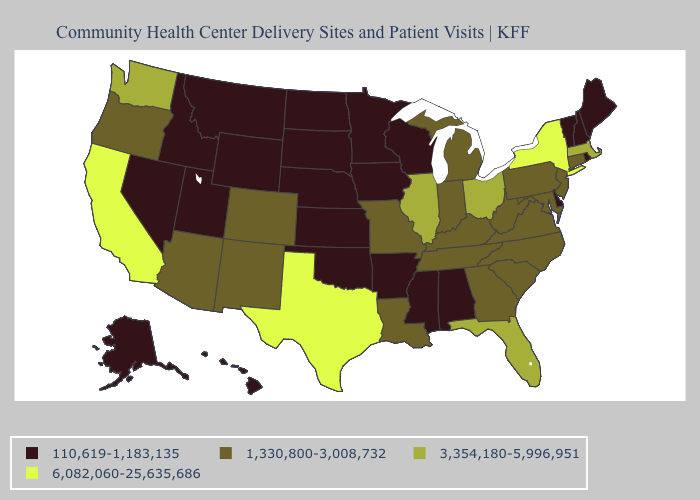Name the states that have a value in the range 3,354,180-5,996,951?
Write a very short answer. Florida, Illinois, Massachusetts, Ohio, Washington. What is the lowest value in the West?
Concise answer only. 110,619-1,183,135. What is the value of Nebraska?
Write a very short answer. 110,619-1,183,135. How many symbols are there in the legend?
Keep it brief. 4. Among the states that border Indiana , does Michigan have the lowest value?
Keep it brief. Yes. Name the states that have a value in the range 3,354,180-5,996,951?
Answer briefly. Florida, Illinois, Massachusetts, Ohio, Washington. Name the states that have a value in the range 3,354,180-5,996,951?
Write a very short answer. Florida, Illinois, Massachusetts, Ohio, Washington. What is the value of Florida?
Give a very brief answer. 3,354,180-5,996,951. What is the value of Kentucky?
Keep it brief. 1,330,800-3,008,732. What is the value of Hawaii?
Write a very short answer. 110,619-1,183,135. Does California have the highest value in the USA?
Short answer required. Yes. Name the states that have a value in the range 1,330,800-3,008,732?
Concise answer only. Arizona, Colorado, Connecticut, Georgia, Indiana, Kentucky, Louisiana, Maryland, Michigan, Missouri, New Jersey, New Mexico, North Carolina, Oregon, Pennsylvania, South Carolina, Tennessee, Virginia, West Virginia. Among the states that border Missouri , does Tennessee have the highest value?
Give a very brief answer. No. What is the highest value in states that border Indiana?
Write a very short answer. 3,354,180-5,996,951. Does Arkansas have the lowest value in the South?
Quick response, please. Yes. 